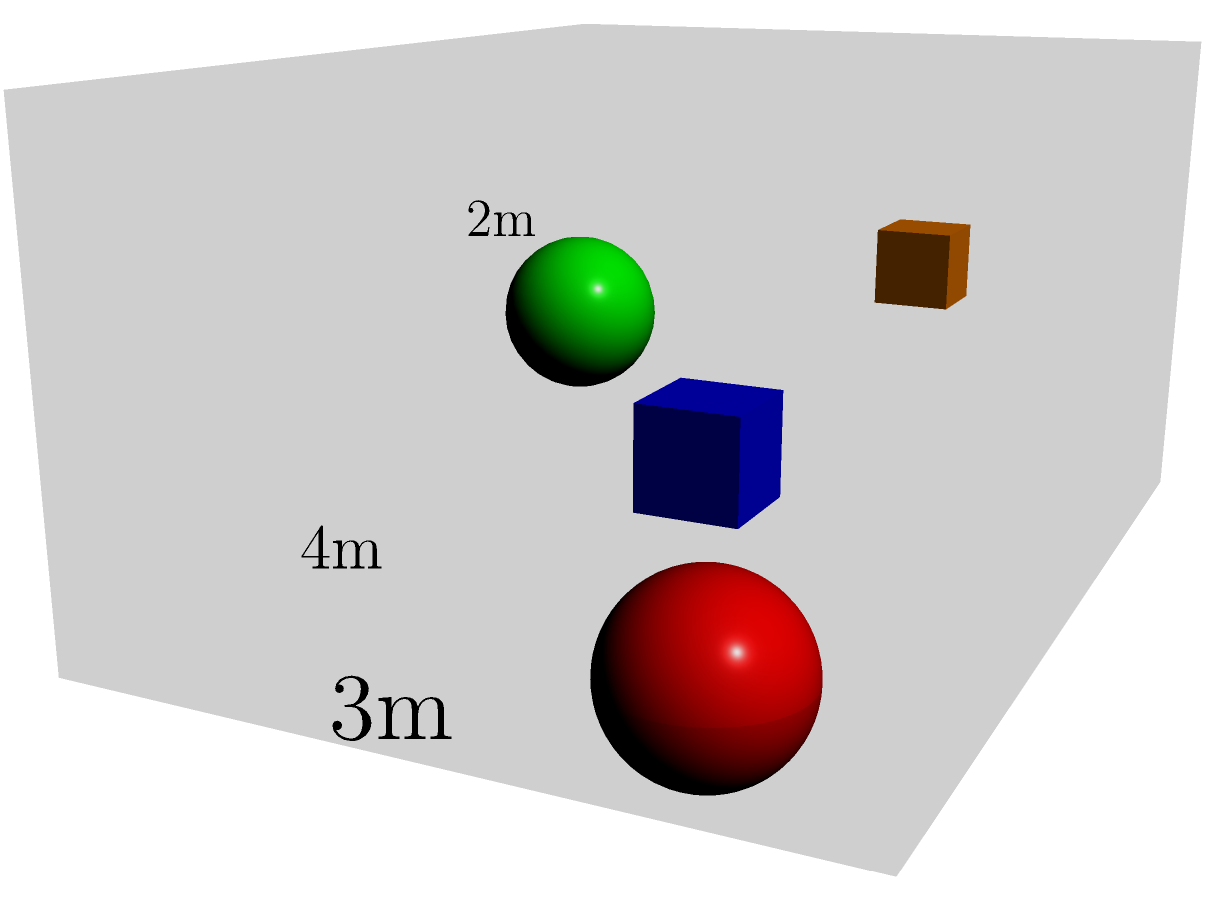As a shadow designer working on an exhibition display, you're tasked with optimizing the arrangement of multiple 3D objects within a limited space. The exhibition area measures 4m x 3m x 2m. Given four objects of various shapes and sizes, what is the maximum volume (in cubic meters) that can be utilized for object placement while ensuring at least 0.5m clearance between objects and from the edges of the exhibition space? To solve this problem, we need to follow these steps:

1. Calculate the total volume of the exhibition space:
   $V_{total} = 4m \times 3m \times 2m = 24m^3$

2. Calculate the volume of the clearance space:
   a. Edges: $0.5m$ clearance on all sides
   b. New dimensions: $(4-1)m \times (3-1)m \times (2-1)m = 3m \times 2m \times 1m$
   c. $V_{clearance} = 3m \times 2m \times 1m = 6m^3$

3. Calculate the available volume for object placement:
   $V_{available} = V_{total} - V_{clearance} = 24m^3 - 6m^3 = 18m^3$

4. Consider the space between objects:
   We need to ensure at least 0.5m between objects. This will further reduce the available volume. A conservative estimate would be to reduce the available volume by approximately 25% to account for this spacing.

5. Calculate the final maximum volume for object placement:
   $V_{max} = V_{available} \times 0.75 = 18m^3 \times 0.75 = 13.5m^3$

Therefore, the maximum volume that can be utilized for object placement while ensuring the required clearances is approximately 13.5 cubic meters.
Answer: 13.5 $m^3$ 